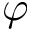Convert formula to latex. <formula><loc_0><loc_0><loc_500><loc_500>\varphi</formula> 